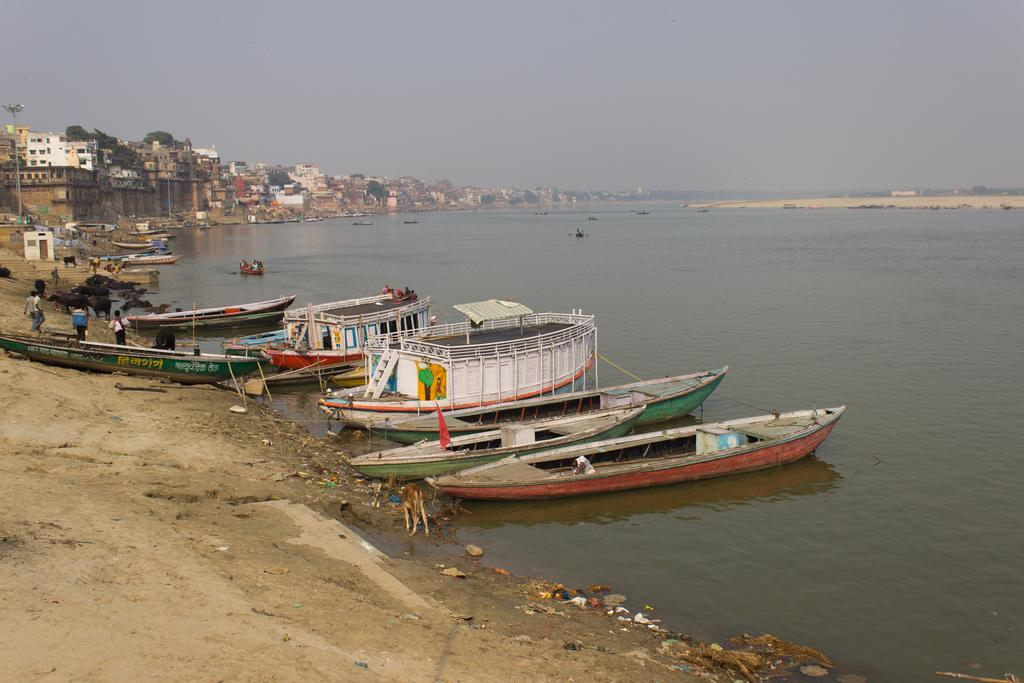What is the main subject in the center of the image? There are boats in the center of the image. Where are the boats located? The boats are on the water. What can be seen in the background of the image? There are buildings in the background of the image. Are there any people visible in the image? Yes, there are persons visible in the image. What type of water body is present in the image? There is a sea in the image. What are the boats doing in the sea? The boats are sailing on the sea. What type of tooth is visible in the image? There is no tooth present in the image. What kind of stone can be seen in the image? There is no stone present in the image. 